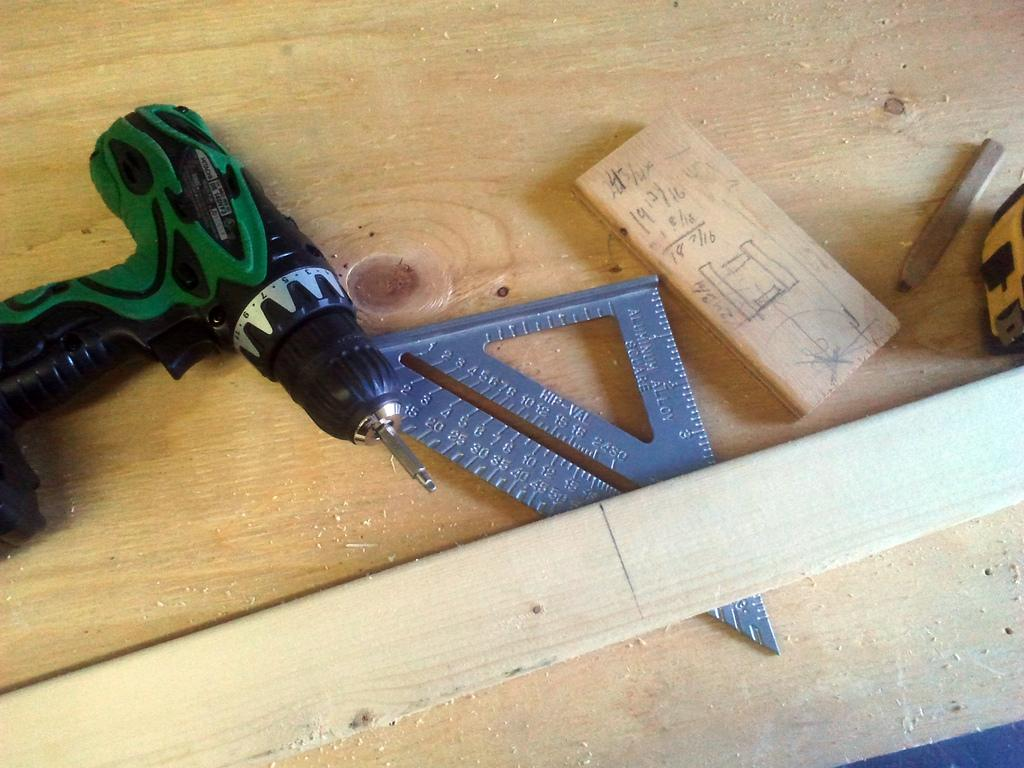<image>
Create a compact narrative representing the image presented. A woodworking project in progress with numbers like 19 12/16 written on wood. 